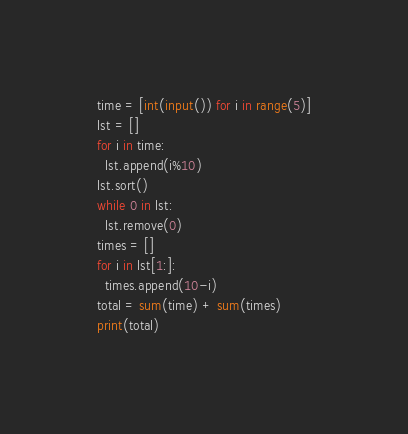Convert code to text. <code><loc_0><loc_0><loc_500><loc_500><_Python_>time = [int(input()) for i in range(5)]
lst = []
for i in time:
  lst.append(i%10)
lst.sort()
while 0 in lst:
  lst.remove(0)
times = []
for i in lst[1:]:
  times.append(10-i)
total = sum(time) + sum(times)
print(total)</code> 